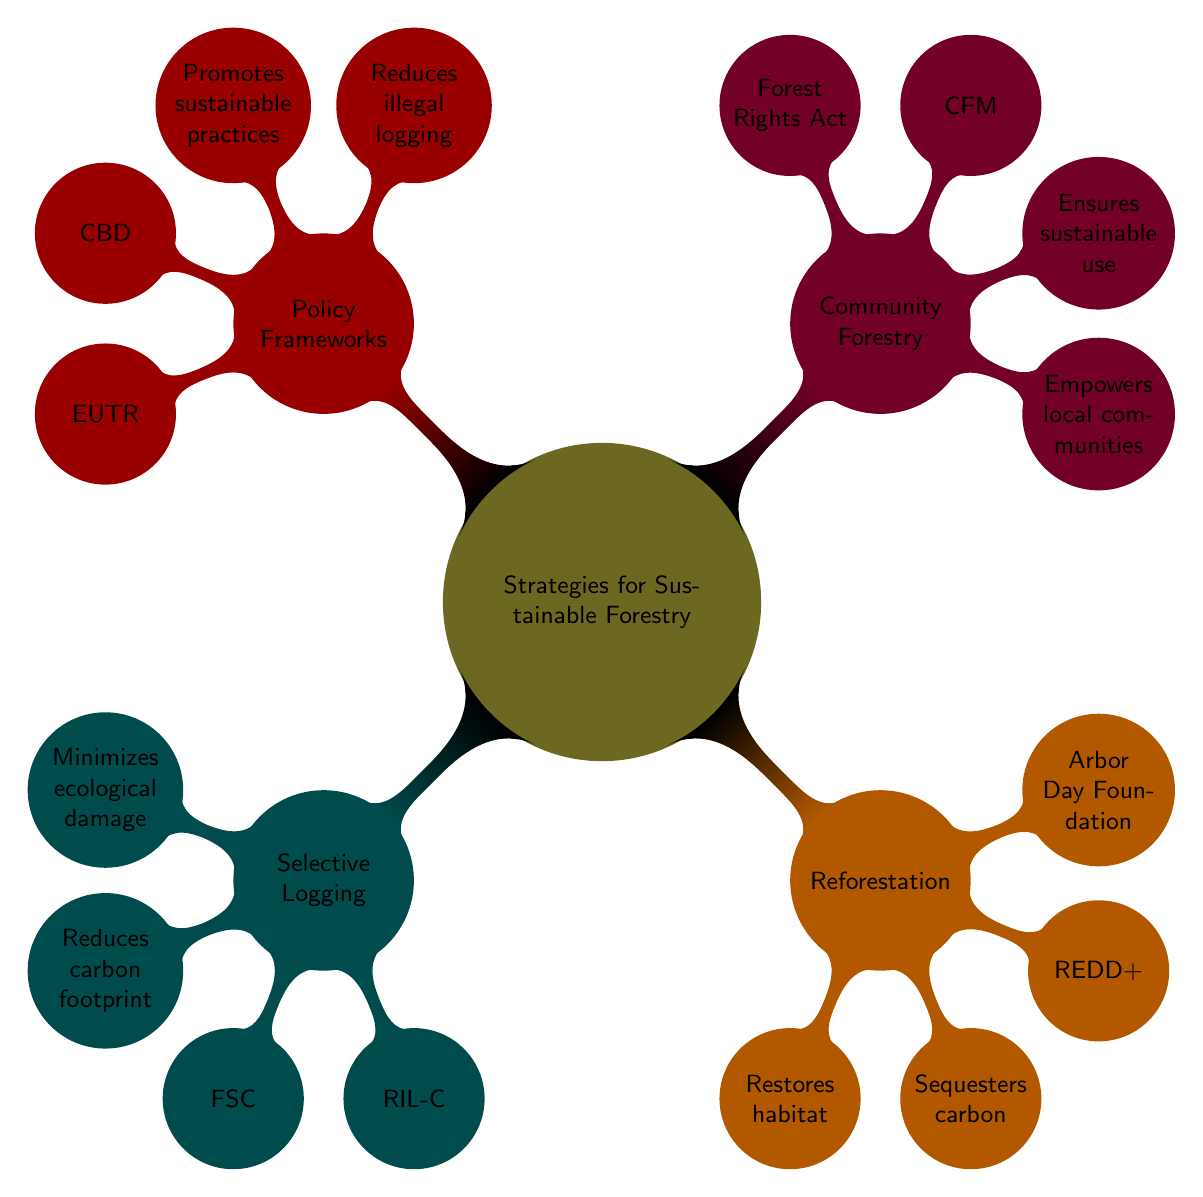What is the main topic of the mind map? The central node of the diagram clearly states the main topic as "Strategies for Sustainable Forestry."
Answer: Strategies for Sustainable Forestry How many main strategies are outlined in the diagram? The diagram branches out into four main strategies: Selective Logging, Reforestation, Community Forestry, and Policy Frameworks. Therefore, the count of main strategies is four.
Answer: 4 What is one benefit of Selective Logging? The diagram indicates several benefits under Selective Logging, one of which is "Minimizes ecological damage."
Answer: Minimizes ecological damage Which entity is associated with Reforestation? One of the entities mentioned in the Reforestation section is the "United Nations REDD+ Programme." Thus, this is the answer to the question.
Answer: United Nations REDD+ Programme What are two benefits listed under Community Forestry? The diagram shows two benefits under Community Forestry: "Empowers local communities" and "Ensures sustainable use." Hence, both of these are relevant answers.
Answer: Empowers local communities, Ensures sustainable use What is the relationship between Policy Frameworks and illegal logging? The diagram highlights that one of the benefits of Policy Frameworks is that it "Reduces illegal logging," showing a direct relationship between the two concepts.
Answer: Reduces illegal logging Which strategy involves the careful selection of trees for logging? The strategy specifically related to the careful selection of trees is "Selective Logging," which is explicitly stated in the diagram.
Answer: Selective Logging What approaches are mentioned under Community Forestry? The diagram lists two approaches for Community Forestry: "Participatory planning" and "Capacity building." Therefore, both these methods are applicable.
Answer: Participatory planning, Capacity building How many benefits does Policy Frameworks provide according to the diagram? Policy Frameworks have two benefits mentioned in the diagram: "Reduces illegal logging" and "Promotes sustainable practices," thus indicating a total of two benefits.
Answer: 2 